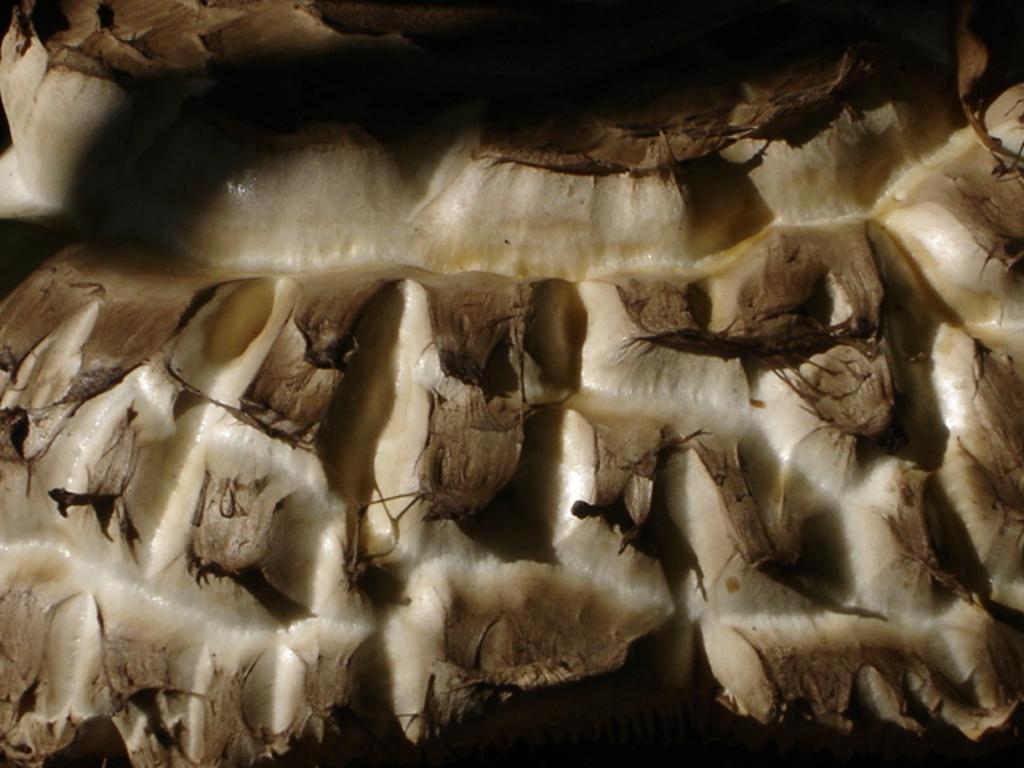Describe this image in one or two sentences. In the picture it looks like a wood. 